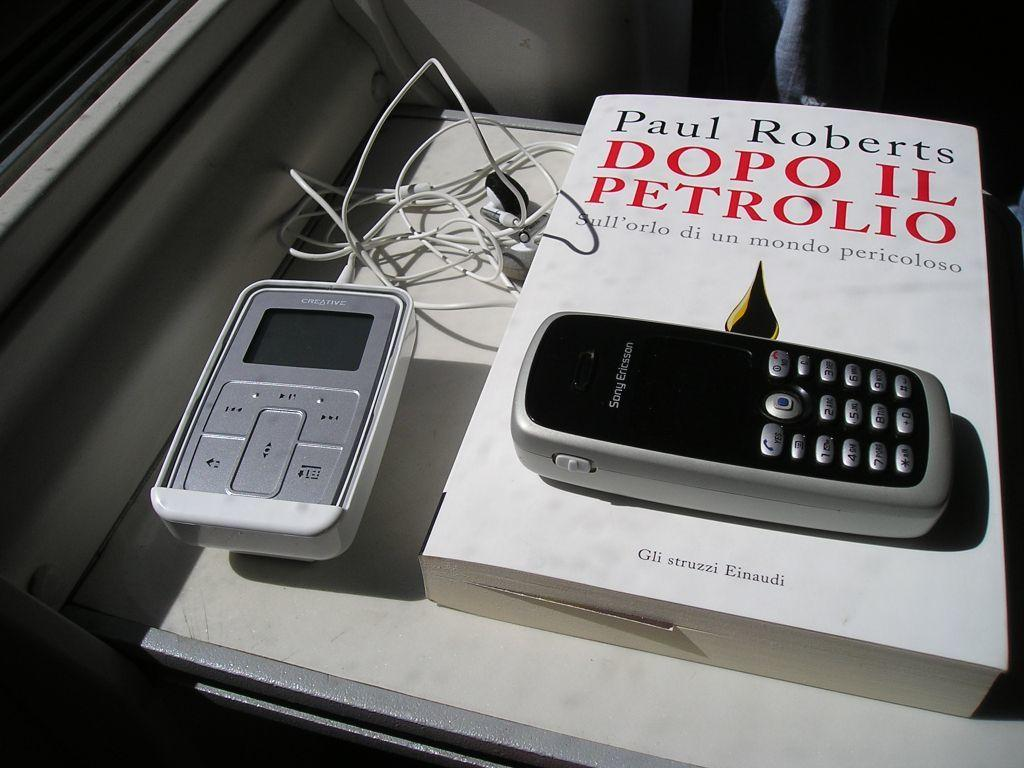<image>
Present a compact description of the photo's key features. An mp3 player, a cell phone, and a Paul Roberts book are on a table. 